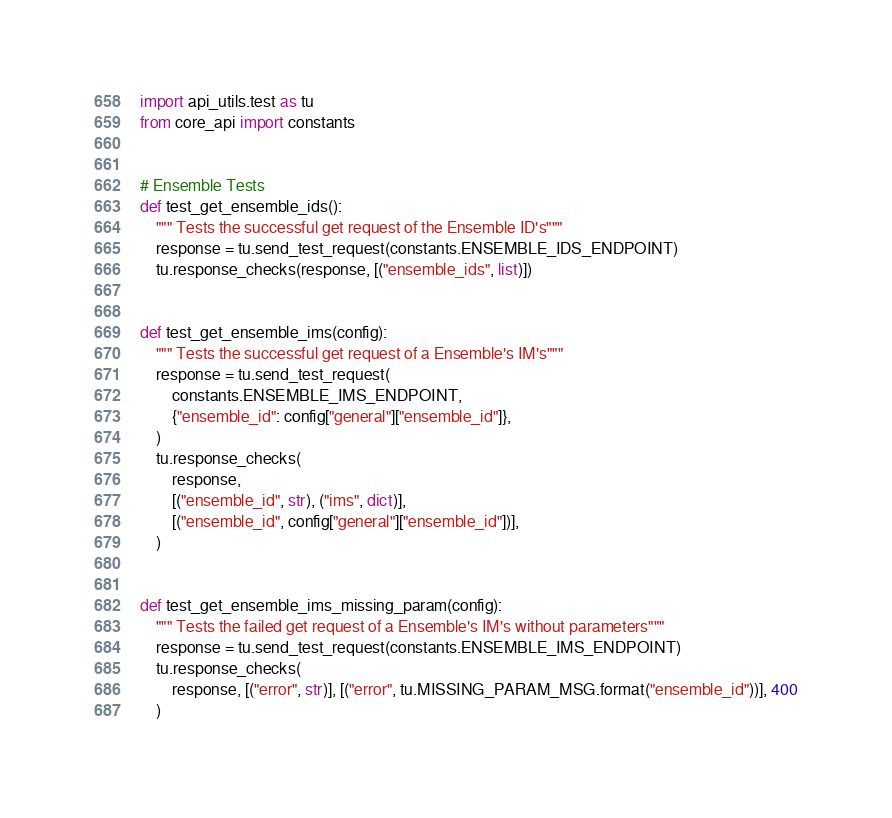<code> <loc_0><loc_0><loc_500><loc_500><_Python_>import api_utils.test as tu
from core_api import constants


# Ensemble Tests
def test_get_ensemble_ids():
    """ Tests the successful get request of the Ensemble ID's"""
    response = tu.send_test_request(constants.ENSEMBLE_IDS_ENDPOINT)
    tu.response_checks(response, [("ensemble_ids", list)])


def test_get_ensemble_ims(config):
    """ Tests the successful get request of a Ensemble's IM's"""
    response = tu.send_test_request(
        constants.ENSEMBLE_IMS_ENDPOINT,
        {"ensemble_id": config["general"]["ensemble_id"]},
    )
    tu.response_checks(
        response,
        [("ensemble_id", str), ("ims", dict)],
        [("ensemble_id", config["general"]["ensemble_id"])],
    )


def test_get_ensemble_ims_missing_param(config):
    """ Tests the failed get request of a Ensemble's IM's without parameters"""
    response = tu.send_test_request(constants.ENSEMBLE_IMS_ENDPOINT)
    tu.response_checks(
        response, [("error", str)], [("error", tu.MISSING_PARAM_MSG.format("ensemble_id"))], 400
    )
</code> 